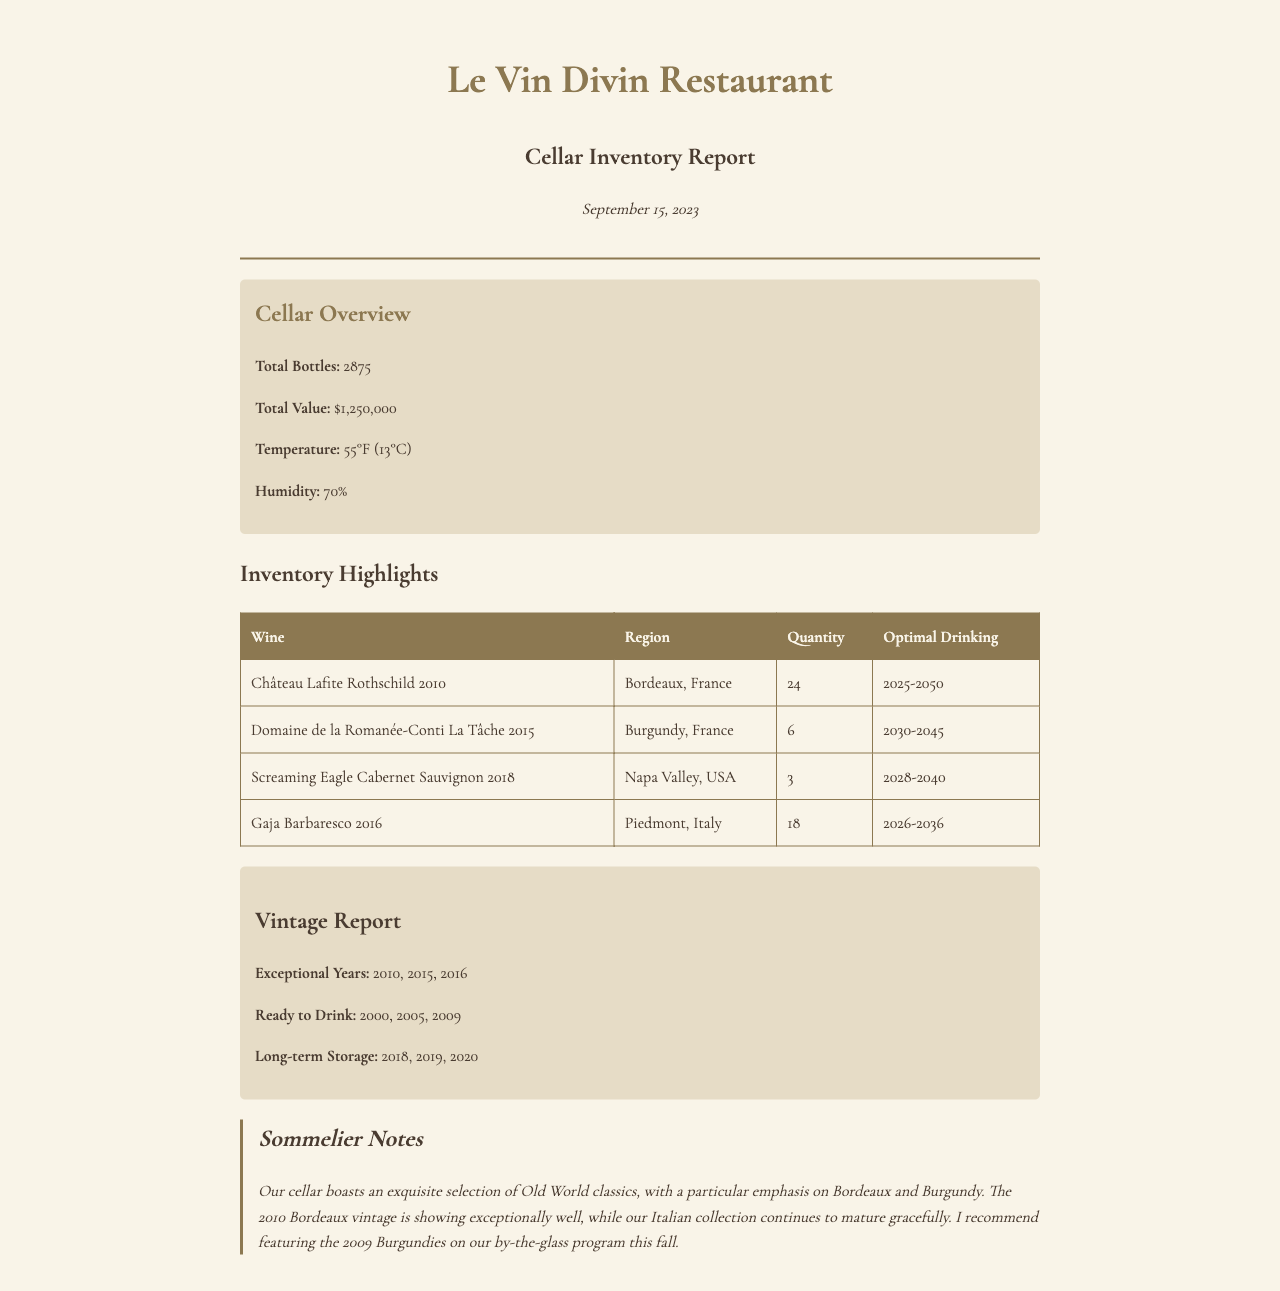what is the total number of bottles? The total number of bottles is listed in the cellar overview section, which states there are 2875 bottles.
Answer: 2875 what is the temperature in the cellar? The temperature of the cellar can be found in the cellar overview section, which indicates it is 55°F.
Answer: 55°F how many bottles of Château Lafite Rothschild 2010 are in inventory? The quantity of Château Lafite Rothschild 2010 in inventory is specified in the inventory highlights table, which shows there are 24 bottles.
Answer: 24 what is the optimal drinking window for Domaine de la Romanée-Conti La Tâche 2015? The optimal drinking window for Domaine de la Romanée-Conti La Tâche 2015 is noted in the inventory highlights table as 2030-2045.
Answer: 2030-2045 which vintage is listed as ready to drink? The vintage report section lists several years, and the ones ready to drink include 2000, 2005, and 2009; any one of these years will suffice as an answer.
Answer: 2000 how many bottles of Screaming Eagle Cabernet Sauvignon 2018 are available? The inventory highlights table specifies that there are 3 bottles of Screaming Eagle Cabernet Sauvignon 2018.
Answer: 3 what years are considered exceptional? The exceptional years are listed in the vintage report section, identifying 2010, 2015, and 2016 as exceptional.
Answer: 2010, 2015, 2016 what is the total value of the cellar? The total value of the cellar is provided in the cellar overview section, stating it is $1,250,000.
Answer: $1,250,000 how many bottles of Gaja Barbaresco 2016 are in stock? The quantity of Gaja Barbaresco 2016 found in the inventory highlights table shows there are 18 bottles available.
Answer: 18 